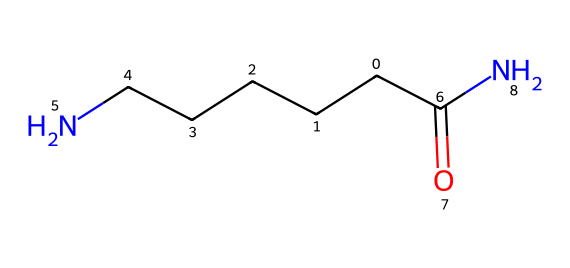What is the main functional group present in this chemical? The structure features a carbonyl group (C=O) which is characteristic of amides, supported by the presence of the nitrogen atom connected to the carbonyl.
Answer: carbonyl How many carbon atoms are in this chemical? By analyzing the structure, there are a total of 5 carbon atoms visible from the linear chain and those in the carbonyl configuration.
Answer: five What type of polymer could be made from this chemical? Given the presence of an amide functional group, this chemical can participate in polymerization processes typical for nylon or similar synthetic fibers.
Answer: nylon What is the degree of saturation in this compound? The chemical contains a carbonyl double bond and several single bonds, indicating a degree of saturation appropriate for a saturated fatty amide.
Answer: saturated Can this chemical be used for marine ropes? Synthetic ropes often utilize chemicals with strong structural integrity and resistance to water, which this chemical, being an amide, provides.
Answer: yes What property makes this chemical suitable for marine applications? The presence of the nitrogen in the amide structure can contribute to beneficial properties such as increased tensile strength and resistance to degradation in marine environments.
Answer: tensile strength 